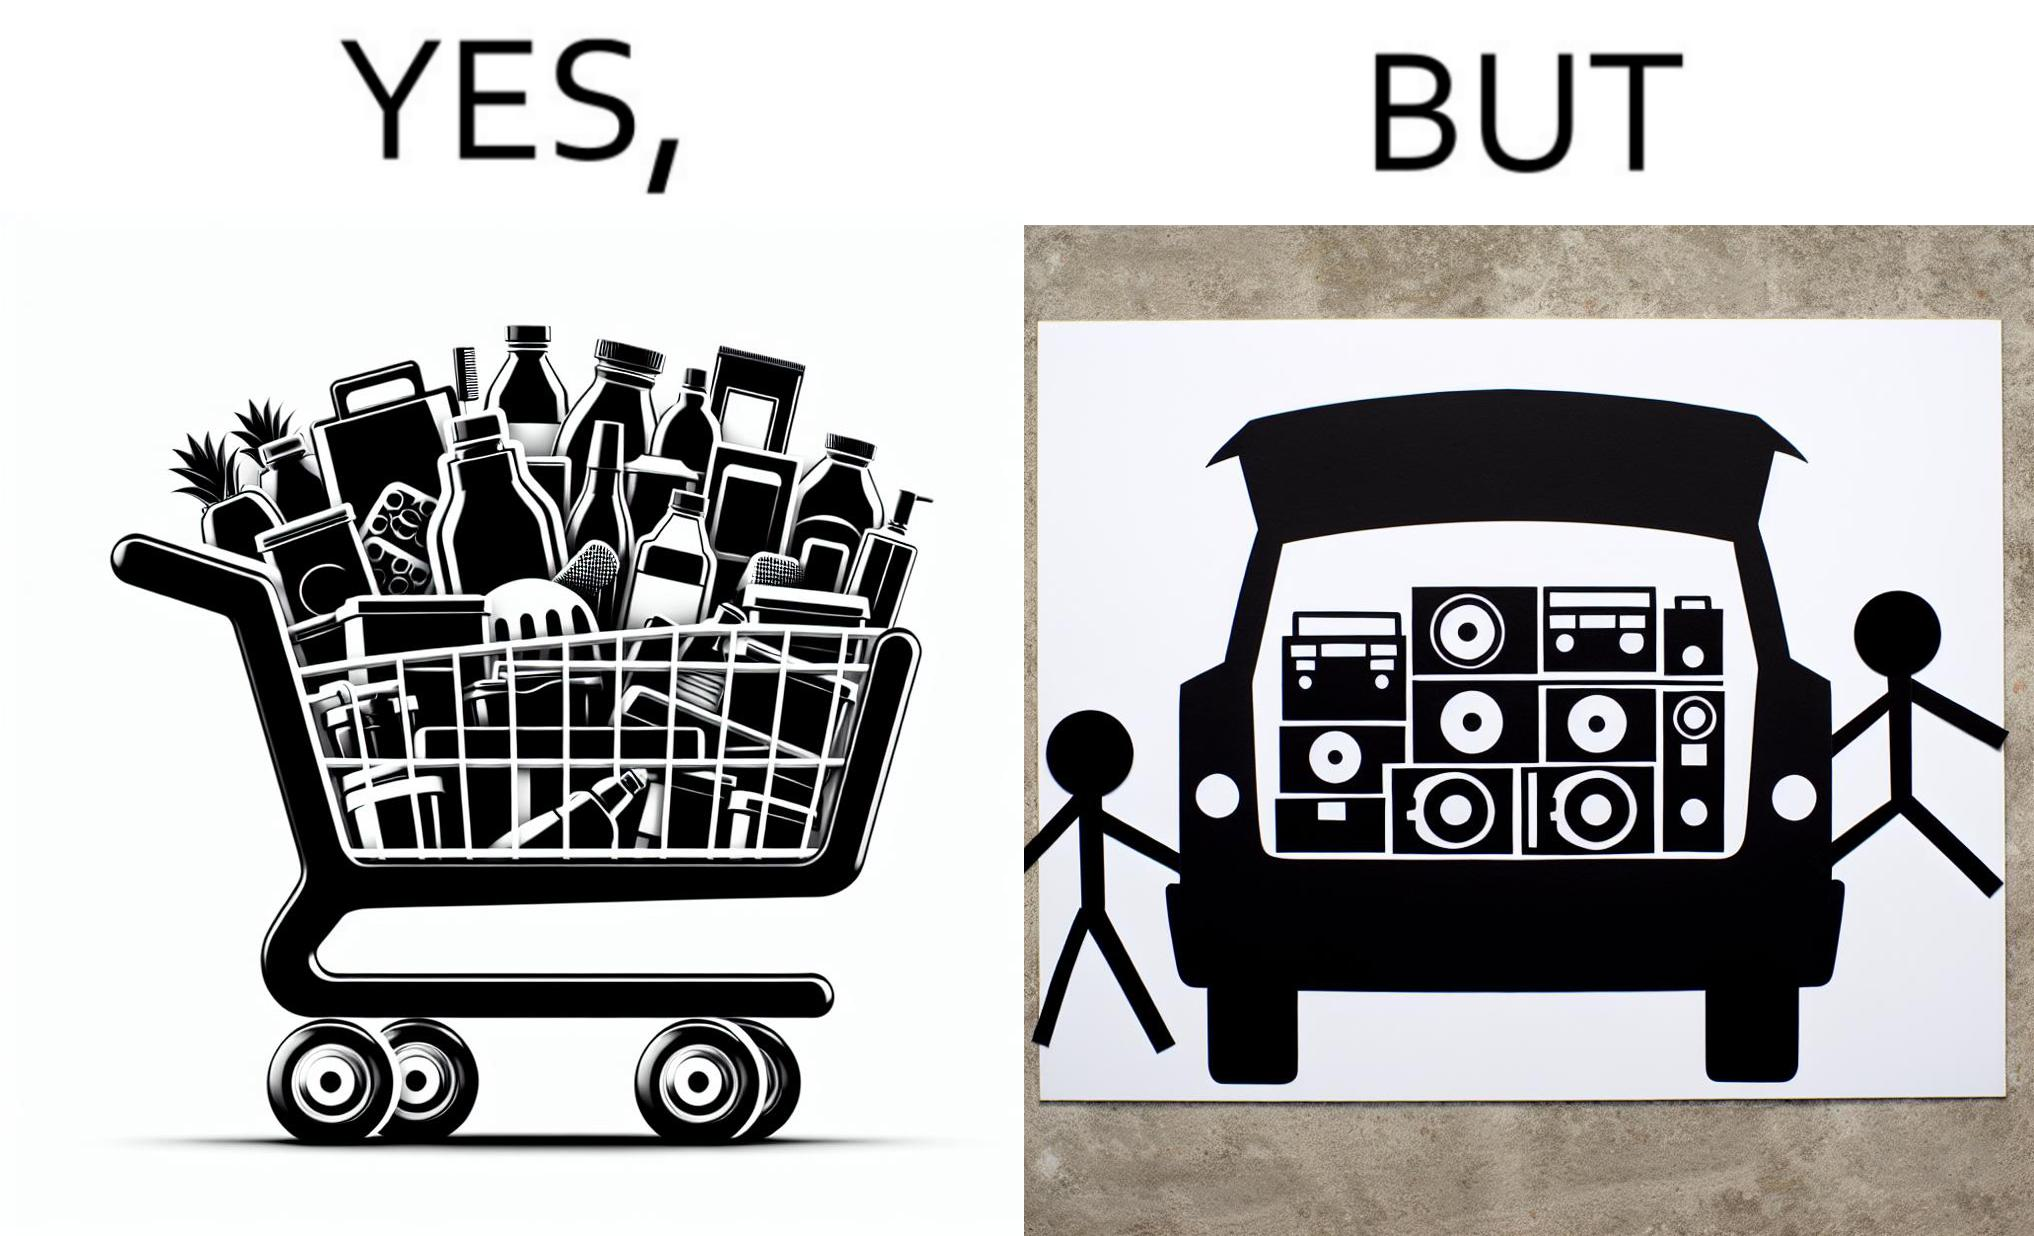Provide a description of this image. The image is ironic, because a car trunk was earlier designed to keep some extra luggage or things but people nowadays get speakers installed in the trunk which in turn reduces the space in the trunk and making it difficult for people to store the extra luggage in the trunk 